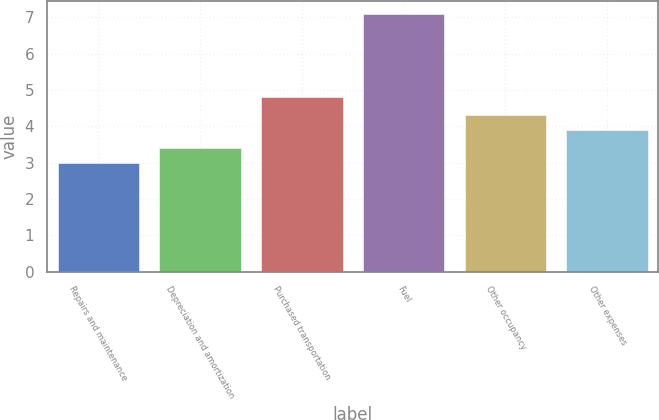Convert chart to OTSL. <chart><loc_0><loc_0><loc_500><loc_500><bar_chart><fcel>Repairs and maintenance<fcel>Depreciation and amortization<fcel>Purchased transportation<fcel>Fuel<fcel>Other occupancy<fcel>Other expenses<nl><fcel>3<fcel>3.41<fcel>4.8<fcel>7.1<fcel>4.31<fcel>3.9<nl></chart> 